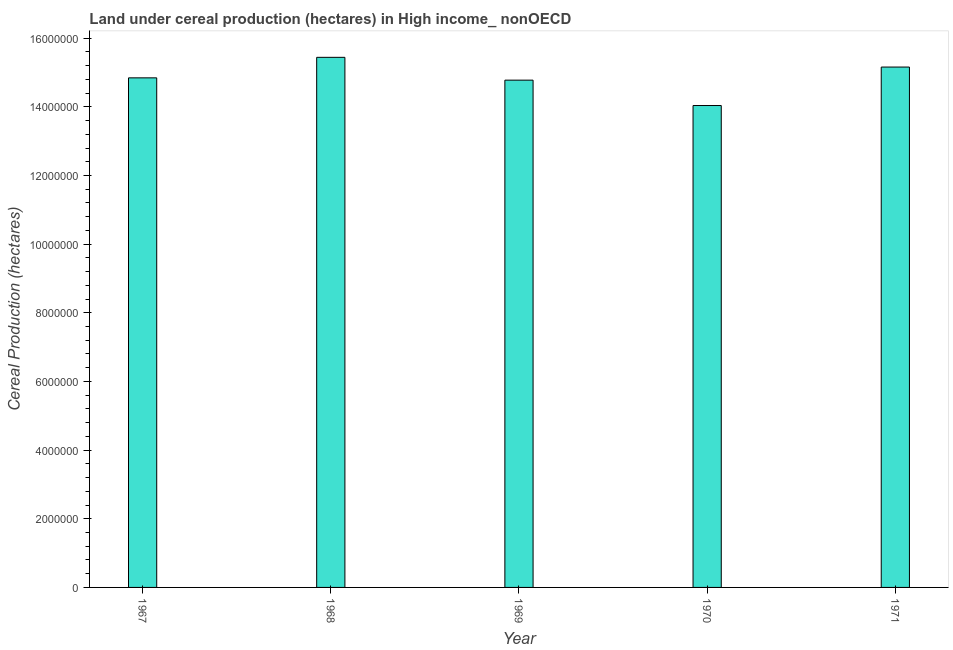Does the graph contain any zero values?
Your answer should be compact. No. What is the title of the graph?
Your answer should be very brief. Land under cereal production (hectares) in High income_ nonOECD. What is the label or title of the X-axis?
Give a very brief answer. Year. What is the label or title of the Y-axis?
Ensure brevity in your answer.  Cereal Production (hectares). What is the land under cereal production in 1968?
Provide a succinct answer. 1.54e+07. Across all years, what is the maximum land under cereal production?
Your answer should be compact. 1.54e+07. Across all years, what is the minimum land under cereal production?
Your answer should be compact. 1.40e+07. In which year was the land under cereal production maximum?
Make the answer very short. 1968. What is the sum of the land under cereal production?
Offer a very short reply. 7.43e+07. What is the difference between the land under cereal production in 1968 and 1970?
Your answer should be compact. 1.40e+06. What is the average land under cereal production per year?
Provide a succinct answer. 1.49e+07. What is the median land under cereal production?
Provide a short and direct response. 1.48e+07. In how many years, is the land under cereal production greater than 3200000 hectares?
Your answer should be compact. 5. Is the land under cereal production in 1967 less than that in 1971?
Make the answer very short. Yes. What is the difference between the highest and the second highest land under cereal production?
Your answer should be compact. 2.83e+05. Is the sum of the land under cereal production in 1967 and 1970 greater than the maximum land under cereal production across all years?
Provide a short and direct response. Yes. What is the difference between the highest and the lowest land under cereal production?
Provide a short and direct response. 1.40e+06. In how many years, is the land under cereal production greater than the average land under cereal production taken over all years?
Your answer should be compact. 2. Are all the bars in the graph horizontal?
Your answer should be compact. No. How many years are there in the graph?
Keep it short and to the point. 5. What is the difference between two consecutive major ticks on the Y-axis?
Provide a short and direct response. 2.00e+06. Are the values on the major ticks of Y-axis written in scientific E-notation?
Offer a very short reply. No. What is the Cereal Production (hectares) in 1967?
Your response must be concise. 1.48e+07. What is the Cereal Production (hectares) in 1968?
Provide a short and direct response. 1.54e+07. What is the Cereal Production (hectares) of 1969?
Your response must be concise. 1.48e+07. What is the Cereal Production (hectares) of 1970?
Offer a very short reply. 1.40e+07. What is the Cereal Production (hectares) of 1971?
Your answer should be very brief. 1.52e+07. What is the difference between the Cereal Production (hectares) in 1967 and 1968?
Offer a terse response. -5.98e+05. What is the difference between the Cereal Production (hectares) in 1967 and 1969?
Your answer should be very brief. 6.68e+04. What is the difference between the Cereal Production (hectares) in 1967 and 1970?
Your answer should be compact. 8.06e+05. What is the difference between the Cereal Production (hectares) in 1967 and 1971?
Provide a succinct answer. -3.14e+05. What is the difference between the Cereal Production (hectares) in 1968 and 1969?
Give a very brief answer. 6.64e+05. What is the difference between the Cereal Production (hectares) in 1968 and 1970?
Your response must be concise. 1.40e+06. What is the difference between the Cereal Production (hectares) in 1968 and 1971?
Provide a succinct answer. 2.83e+05. What is the difference between the Cereal Production (hectares) in 1969 and 1970?
Offer a terse response. 7.39e+05. What is the difference between the Cereal Production (hectares) in 1969 and 1971?
Ensure brevity in your answer.  -3.81e+05. What is the difference between the Cereal Production (hectares) in 1970 and 1971?
Keep it short and to the point. -1.12e+06. What is the ratio of the Cereal Production (hectares) in 1967 to that in 1968?
Provide a succinct answer. 0.96. What is the ratio of the Cereal Production (hectares) in 1967 to that in 1969?
Offer a terse response. 1. What is the ratio of the Cereal Production (hectares) in 1967 to that in 1970?
Keep it short and to the point. 1.06. What is the ratio of the Cereal Production (hectares) in 1967 to that in 1971?
Your response must be concise. 0.98. What is the ratio of the Cereal Production (hectares) in 1968 to that in 1969?
Keep it short and to the point. 1.04. What is the ratio of the Cereal Production (hectares) in 1968 to that in 1971?
Your answer should be compact. 1.02. What is the ratio of the Cereal Production (hectares) in 1969 to that in 1970?
Your response must be concise. 1.05. What is the ratio of the Cereal Production (hectares) in 1970 to that in 1971?
Your answer should be compact. 0.93. 